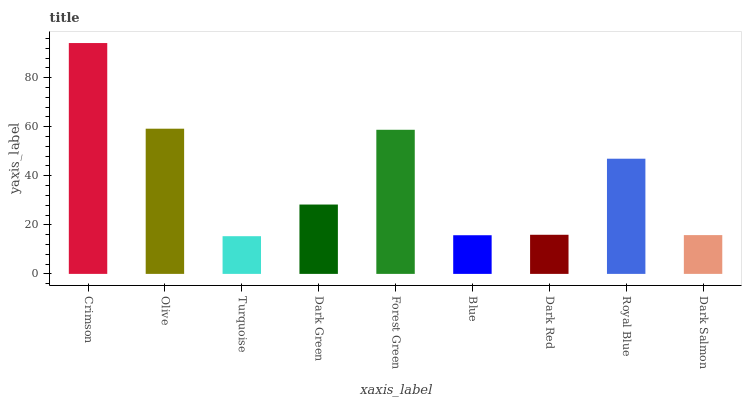Is Turquoise the minimum?
Answer yes or no. Yes. Is Crimson the maximum?
Answer yes or no. Yes. Is Olive the minimum?
Answer yes or no. No. Is Olive the maximum?
Answer yes or no. No. Is Crimson greater than Olive?
Answer yes or no. Yes. Is Olive less than Crimson?
Answer yes or no. Yes. Is Olive greater than Crimson?
Answer yes or no. No. Is Crimson less than Olive?
Answer yes or no. No. Is Dark Green the high median?
Answer yes or no. Yes. Is Dark Green the low median?
Answer yes or no. Yes. Is Turquoise the high median?
Answer yes or no. No. Is Crimson the low median?
Answer yes or no. No. 